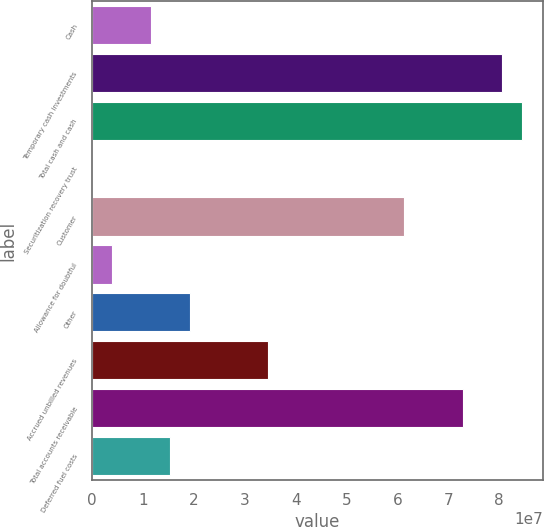Convert chart to OTSL. <chart><loc_0><loc_0><loc_500><loc_500><bar_chart><fcel>Cash<fcel>Temporary cash investments<fcel>Total cash and cash<fcel>Securitization recovery trust<fcel>Customer<fcel>Allowance for doubtful<fcel>Other<fcel>Accrued unbilled revenues<fcel>Total accounts receivable<fcel>Deferred fuel costs<nl><fcel>1.15163e+07<fcel>8.05419e+07<fcel>8.43767e+07<fcel>12062<fcel>6.13682e+07<fcel>3.84682e+06<fcel>1.91858e+07<fcel>3.45249e+07<fcel>7.28724e+07<fcel>1.53511e+07<nl></chart> 